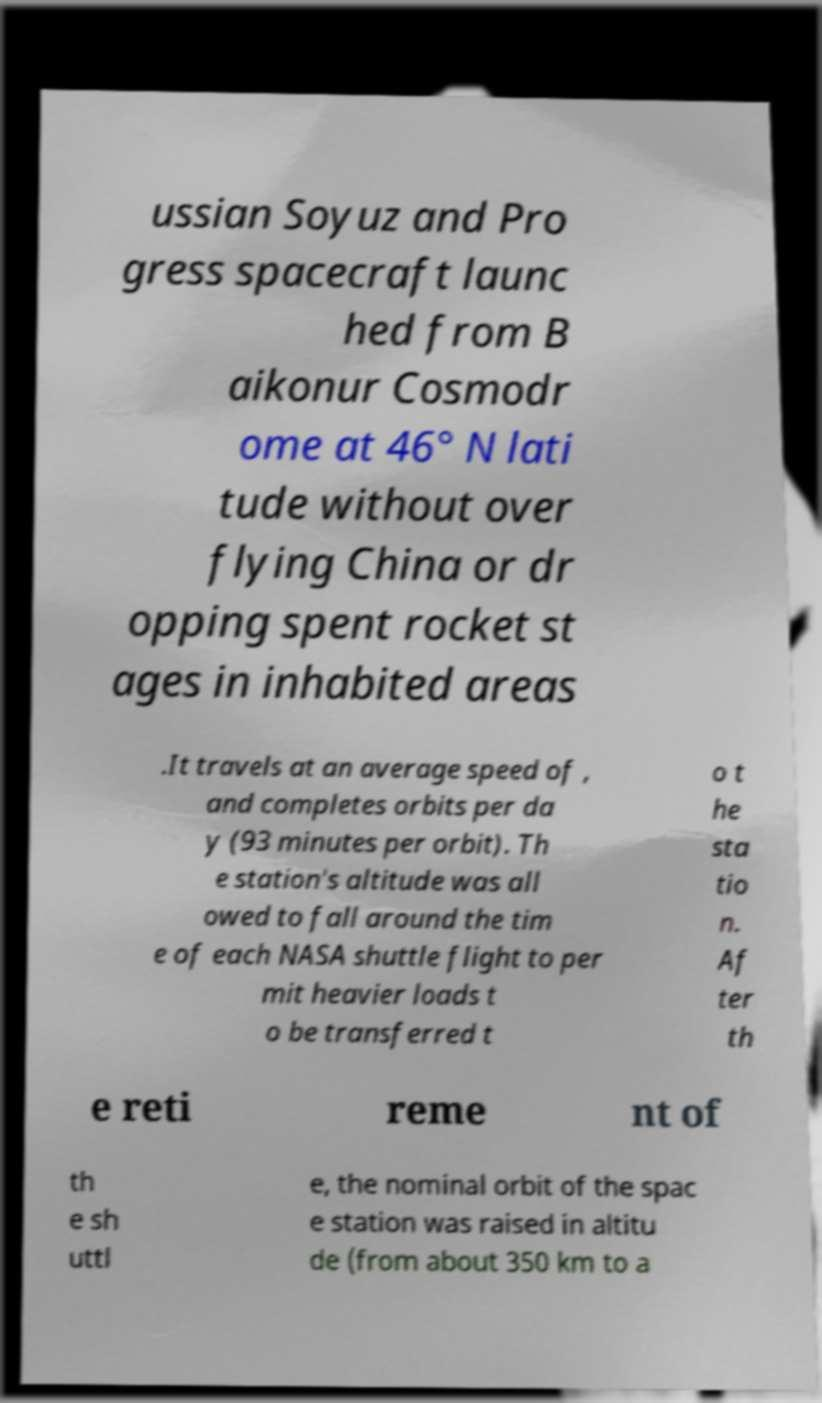Could you extract and type out the text from this image? ussian Soyuz and Pro gress spacecraft launc hed from B aikonur Cosmodr ome at 46° N lati tude without over flying China or dr opping spent rocket st ages in inhabited areas .It travels at an average speed of , and completes orbits per da y (93 minutes per orbit). Th e station's altitude was all owed to fall around the tim e of each NASA shuttle flight to per mit heavier loads t o be transferred t o t he sta tio n. Af ter th e reti reme nt of th e sh uttl e, the nominal orbit of the spac e station was raised in altitu de (from about 350 km to a 